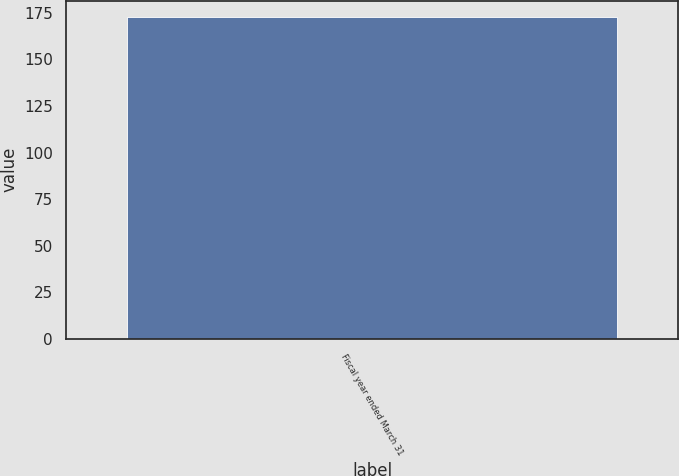Convert chart. <chart><loc_0><loc_0><loc_500><loc_500><bar_chart><fcel>Fiscal year ended March 31<nl><fcel>173<nl></chart> 